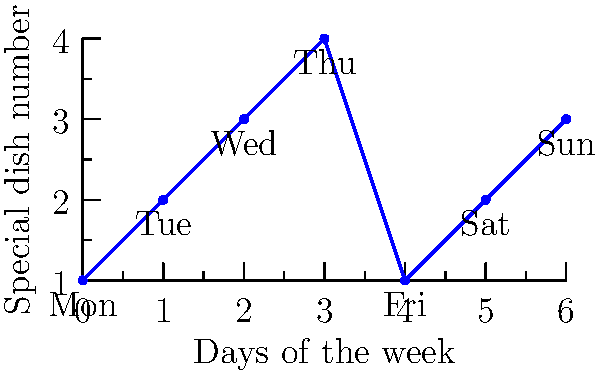Ristorante Machiavelli has introduced a new weekly specials menu that follows a cyclic pattern. The graph shows the special dish number for each day of the week. If the pattern continues indefinitely, what is the order of the cyclic group formed by this menu rotation? To determine the order of the cyclic group formed by this menu rotation, we need to follow these steps:

1. Observe the pattern in the graph:
   - Monday (Day 0): Special 1
   - Tuesday (Day 1): Special 2
   - Wednesday (Day 2): Special 3
   - Thursday (Day 3): Special 4
   - Friday (Day 4): Special 1 (repeats)
   - Saturday (Day 5): Special 2 (repeats)
   - Sunday (Day 6): Special 3 (repeats)

2. Identify the cycle length:
   The pattern repeats after 4 days (Monday to Thursday).

3. Understand the group structure:
   - The cyclic group is generated by the daily rotation of specials.
   - Each element of the group represents a specific day's menu.
   - The identity element is the initial state (Monday's menu).

4. Determine the order of the group:
   - The order of a cyclic group is the smallest positive integer $n$ such that $g^n = e$, where $g$ is the generator and $e$ is the identity element.
   - In this case, applying the rotation 4 times brings us back to the initial state.

5. Conclude:
   The order of the cyclic group is 4, as it takes 4 rotations to return to the initial state.

This cyclic group can be represented as $C_4$ or $\mathbb{Z}/4\mathbb{Z}$.
Answer: 4 